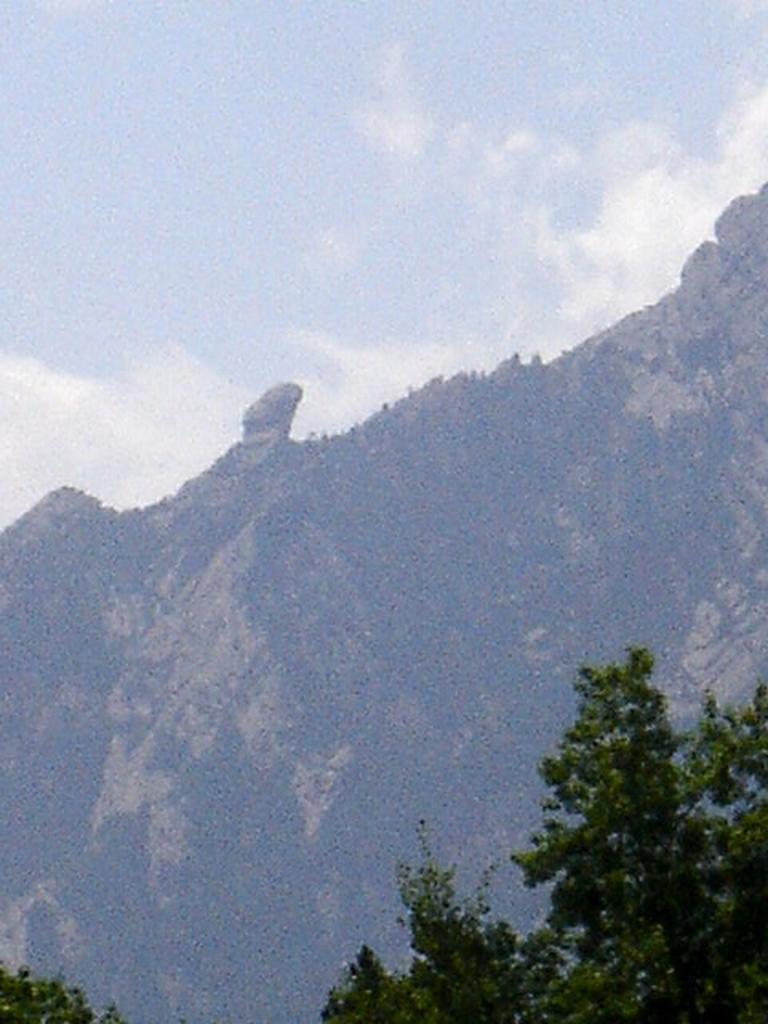What type of vegetation can be seen in the image? There are trees in the image. What natural features are visible in the background of the image? There are mountains and clouds in the background of the image. What part of the natural environment is visible in the image? The sky is visible in the background of the image. How many pets are visible in the image? There are no pets present in the image. What type of regret can be seen on the trees in the image? There is no regret visible in the image; it only features trees, mountains, clouds, and the sky. 